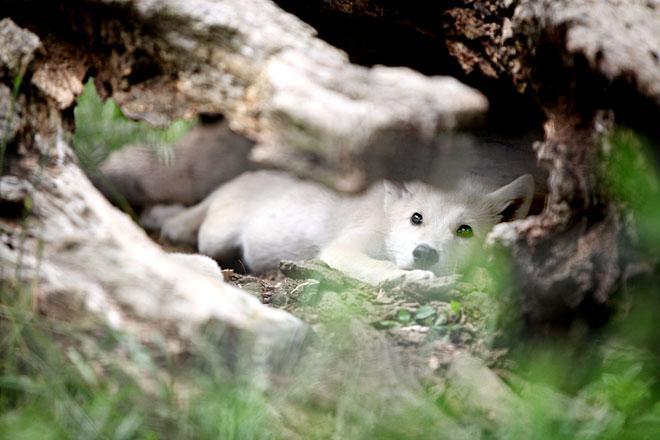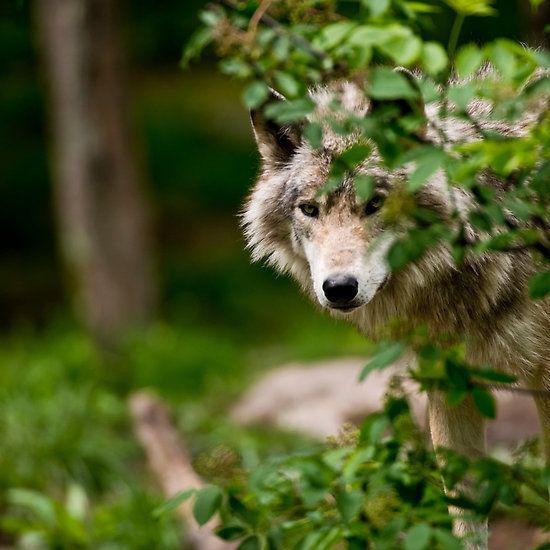The first image is the image on the left, the second image is the image on the right. Analyze the images presented: Is the assertion "There is a single wolf with its face partially covered by foliage in one of the images." valid? Answer yes or no. Yes. The first image is the image on the left, the second image is the image on the right. Given the left and right images, does the statement "The right image features an adult wolf with left-turned face next to multiple pups." hold true? Answer yes or no. No. 